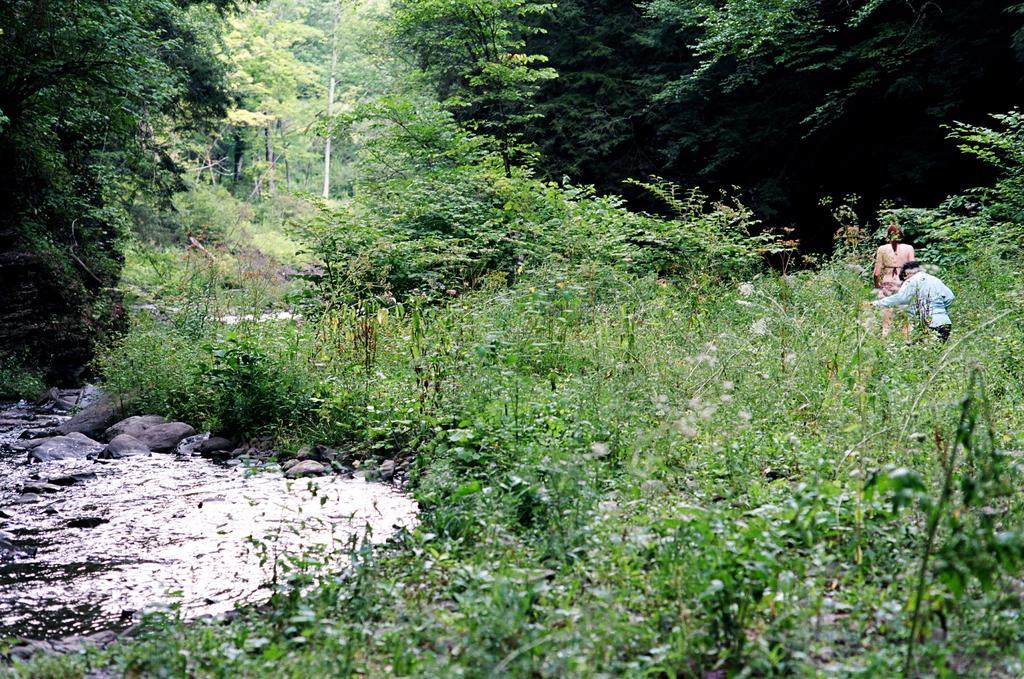Please provide a concise description of this image. In this image I can see the water, few rocks, few plants which are green in color and two persons standing on the ground. In the background I can see few trees which are green in color. 